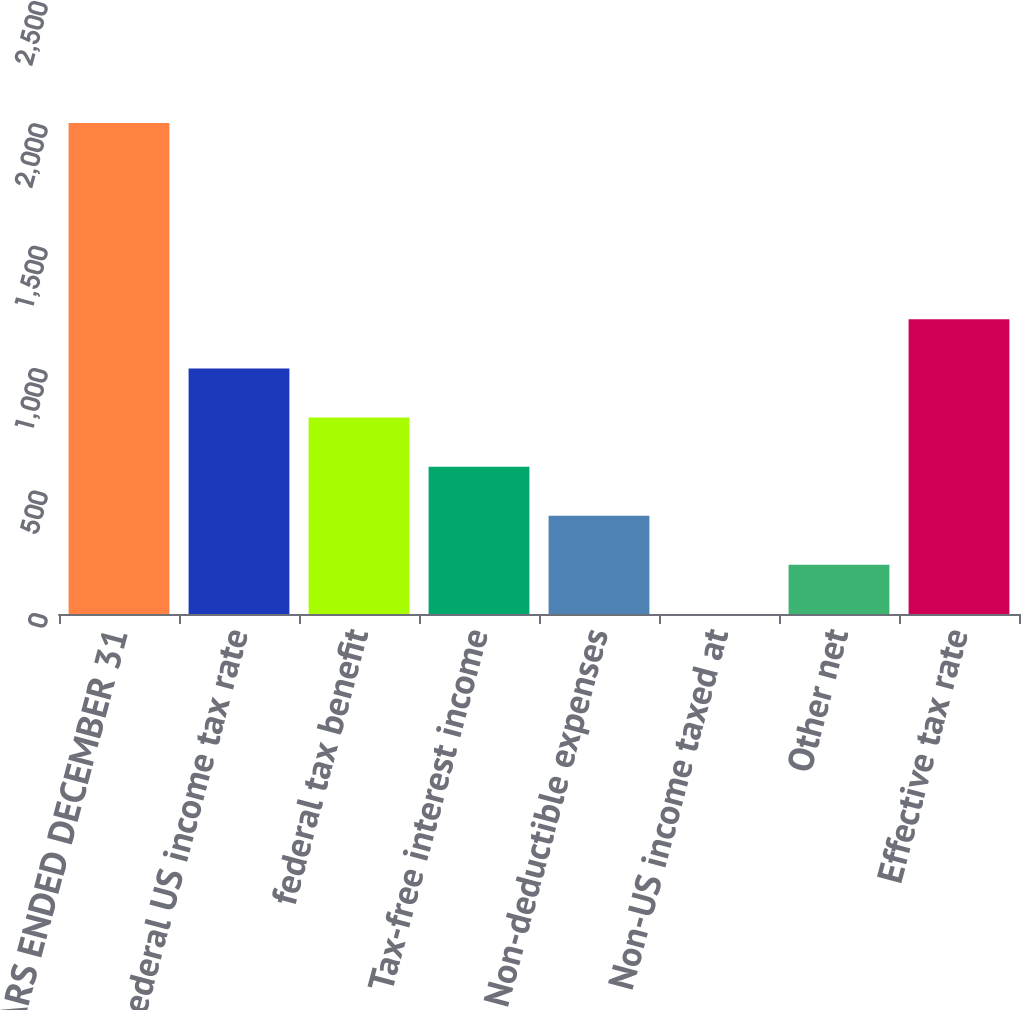Convert chart to OTSL. <chart><loc_0><loc_0><loc_500><loc_500><bar_chart><fcel>YEARS ENDED DECEMBER 31<fcel>Federal US income tax rate<fcel>federal tax benefit<fcel>Tax-free interest income<fcel>Non-deductible expenses<fcel>Non-US income taxed at<fcel>Other net<fcel>Effective tax rate<nl><fcel>2006<fcel>1003.05<fcel>802.46<fcel>601.87<fcel>401.28<fcel>0.1<fcel>200.69<fcel>1203.64<nl></chart> 